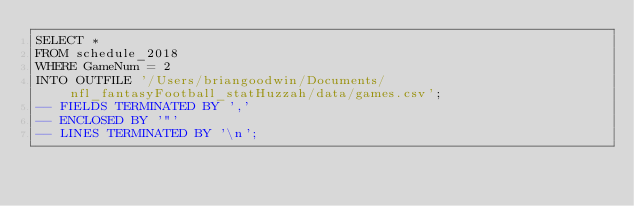<code> <loc_0><loc_0><loc_500><loc_500><_SQL_>SELECT *
FROM schedule_2018
WHERE GameNum = 2
INTO OUTFILE '/Users/briangoodwin/Documents/nfl_fantasyFootball_statHuzzah/data/games.csv';
-- FIELDS TERMINATED BY ','
-- ENCLOSED BY '"'
-- LINES TERMINATED BY '\n';</code> 